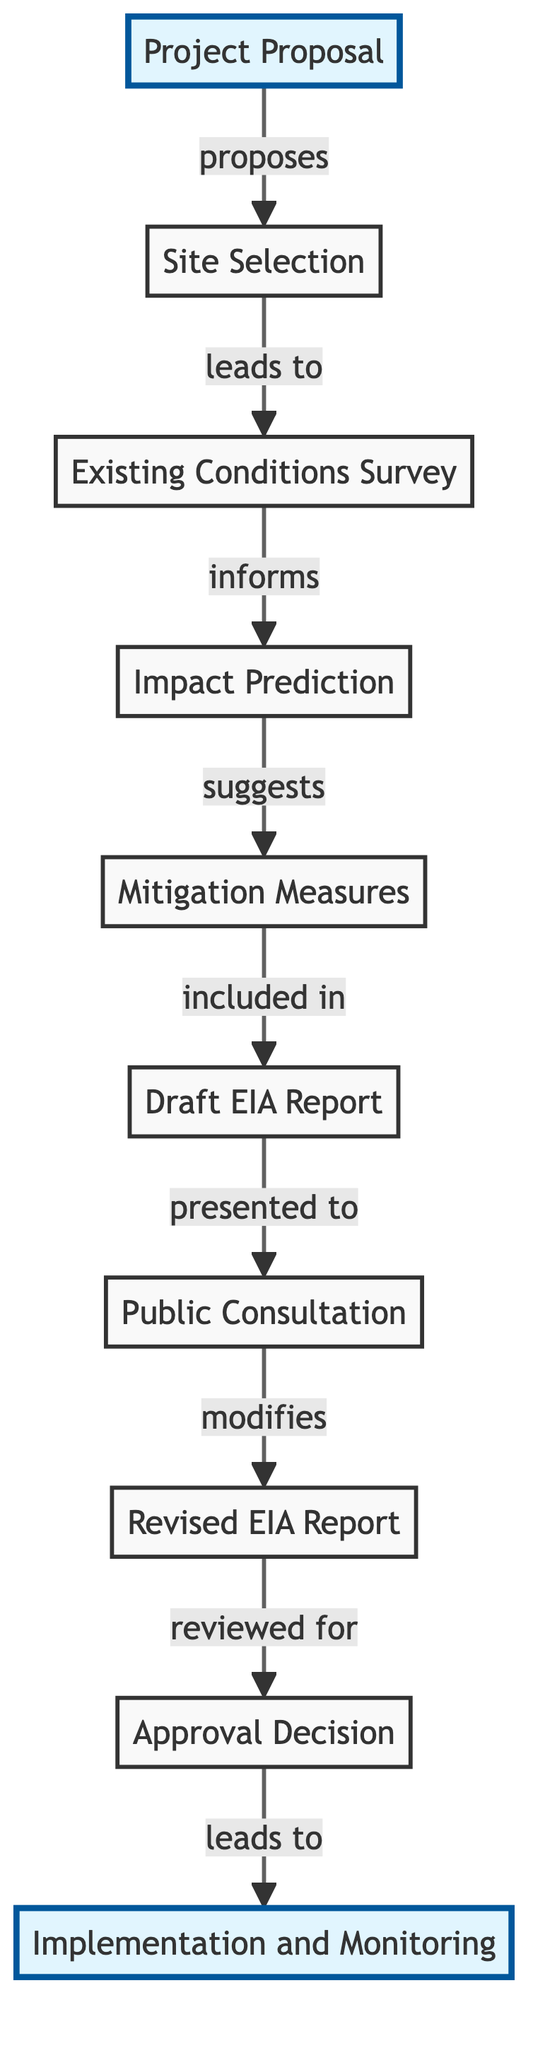What is the first step in the Environmental Impact Assessment Procedure? The first node in the diagram is "Project Proposal," which indicates the initial step in the procedure.
Answer: Project Proposal How many nodes are in the diagram? The diagram displays a total of 10 nodes, each representing different stages in the Environmental Impact Assessment Procedure.
Answer: 10 What action does "Impact Prediction" suggest? The edge from "Impact Prediction" to "Mitigation Measures" is labeled "suggests," indicating that the prediction informs the identification of actions to mitigate environmental impacts.
Answer: Mitigation Measures Which node follows "Public Consultation"? The edge leading from "Public Consultation" to "Revised EIA Report" shows that the output of the consultation modifies the existing report, indicating that "Revised EIA Report" follows it.
Answer: Revised EIA Report What does the "Draft EIA Report" present to? According to the connection from "Draft EIA Report," it is presented to the "Public Consultation," indicating that this is the target audience for the report.
Answer: Public Consultation Which node has an edge leading to "Implementation and Monitoring"? The edge from "Approval Decision" to "Implementation and Monitoring" shows the progression from receiving the approval to executing and monitoring the project's impacts.
Answer: Approval Decision Explain the relationship sequence starting from "Site Selection" to "Approval Decision." "Site Selection" leads to "Existing Conditions Survey," which informs "Impact Prediction." The prediction suggests "Mitigation Measures," which are included in the "Draft EIA Report." The report is presented to "Public Consultation," and the feedback modifies this report into the "Revised EIA Report." Finally, the revised report is reviewed for the "Approval Decision," completing the sequence.
Answer: Site Selection → Existing Conditions Survey → Impact Prediction → Mitigation Measures → Draft EIA Report → Public Consultation → Revised EIA Report → Approval Decision What is the outcome following the "Approval Decision"? The diagram indicates that the "Approval Decision" leads to "Implementation and Monitoring," signifying that the decision results in the execution of the project.
Answer: Implementation and Monitoring Which two nodes are directly connected by the relationship labeled "included in"? The relationship labeled "included in" connects "Mitigation Measures" and "Draft EIA Report," indicating that the measures are documented within the report.
Answer: Mitigation Measures, Draft EIA Report 